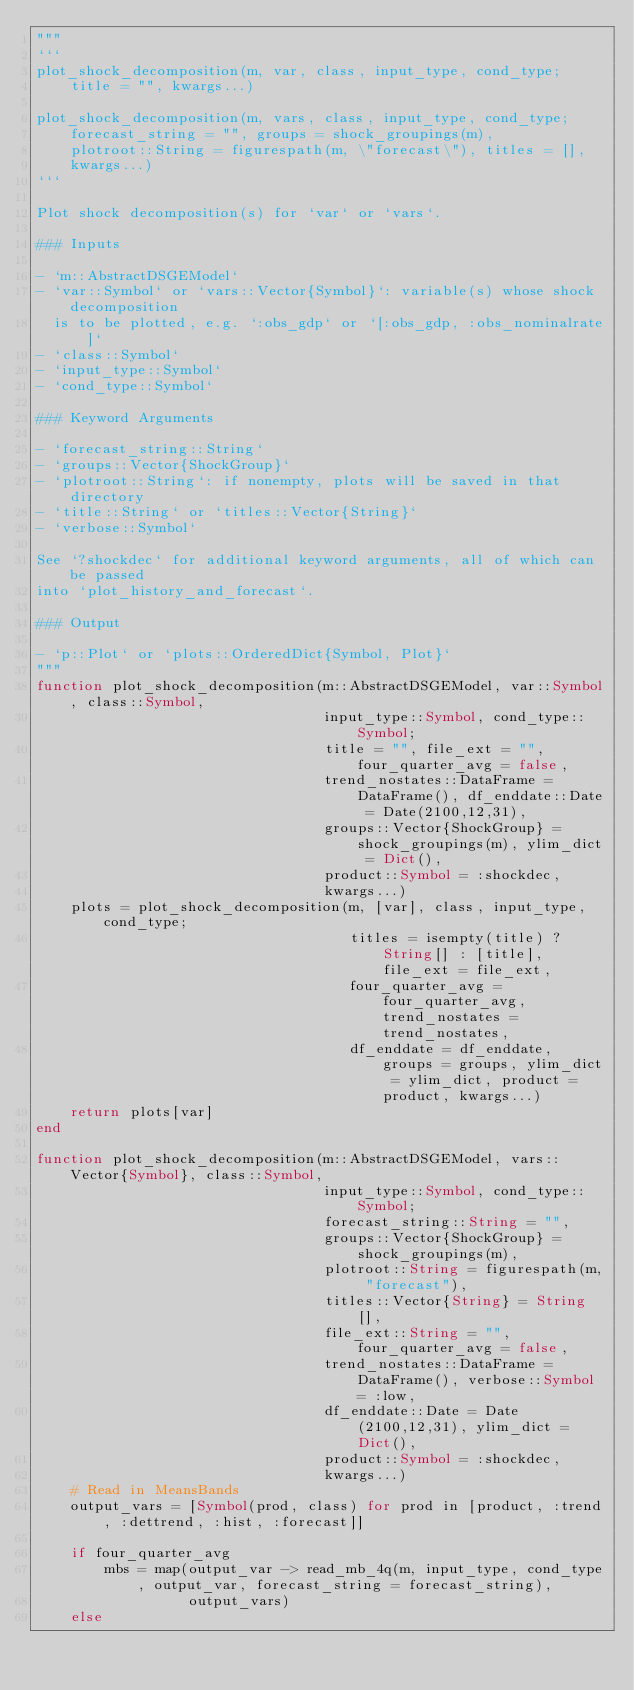Convert code to text. <code><loc_0><loc_0><loc_500><loc_500><_Julia_>"""
```
plot_shock_decomposition(m, var, class, input_type, cond_type;
    title = "", kwargs...)

plot_shock_decomposition(m, vars, class, input_type, cond_type;
    forecast_string = "", groups = shock_groupings(m),
    plotroot::String = figurespath(m, \"forecast\"), titles = [],
    kwargs...)
```

Plot shock decomposition(s) for `var` or `vars`.

### Inputs

- `m::AbstractDSGEModel`
- `var::Symbol` or `vars::Vector{Symbol}`: variable(s) whose shock decomposition
  is to be plotted, e.g. `:obs_gdp` or `[:obs_gdp, :obs_nominalrate]`
- `class::Symbol`
- `input_type::Symbol`
- `cond_type::Symbol`

### Keyword Arguments

- `forecast_string::String`
- `groups::Vector{ShockGroup}`
- `plotroot::String`: if nonempty, plots will be saved in that directory
- `title::String` or `titles::Vector{String}`
- `verbose::Symbol`

See `?shockdec` for additional keyword arguments, all of which can be passed
into `plot_history_and_forecast`.

### Output

- `p::Plot` or `plots::OrderedDict{Symbol, Plot}`
"""
function plot_shock_decomposition(m::AbstractDSGEModel, var::Symbol, class::Symbol,
                                  input_type::Symbol, cond_type::Symbol;
                                  title = "", file_ext = "", four_quarter_avg = false,
                                  trend_nostates::DataFrame = DataFrame(), df_enddate::Date = Date(2100,12,31),
                                  groups::Vector{ShockGroup} = shock_groupings(m), ylim_dict = Dict(),
                                  product::Symbol = :shockdec,
                                  kwargs...)
    plots = plot_shock_decomposition(m, [var], class, input_type, cond_type;
                                     titles = isempty(title) ? String[] : [title], file_ext = file_ext,
                                     four_quarter_avg = four_quarter_avg, trend_nostates = trend_nostates,
                                     df_enddate = df_enddate, groups = groups, ylim_dict = ylim_dict, product = product, kwargs...)
    return plots[var]
end

function plot_shock_decomposition(m::AbstractDSGEModel, vars::Vector{Symbol}, class::Symbol,
                                  input_type::Symbol, cond_type::Symbol;
                                  forecast_string::String = "",
                                  groups::Vector{ShockGroup} = shock_groupings(m),
                                  plotroot::String = figurespath(m, "forecast"),
                                  titles::Vector{String} = String[],
                                  file_ext::String = "", four_quarter_avg = false,
                                  trend_nostates::DataFrame = DataFrame(), verbose::Symbol = :low,
                                  df_enddate::Date = Date(2100,12,31), ylim_dict = Dict(),
                                  product::Symbol = :shockdec,
                                  kwargs...)
    # Read in MeansBands
    output_vars = [Symbol(prod, class) for prod in [product, :trend, :dettrend, :hist, :forecast]]

    if four_quarter_avg
        mbs = map(output_var -> read_mb_4q(m, input_type, cond_type, output_var, forecast_string = forecast_string),
                  output_vars)
    else</code> 